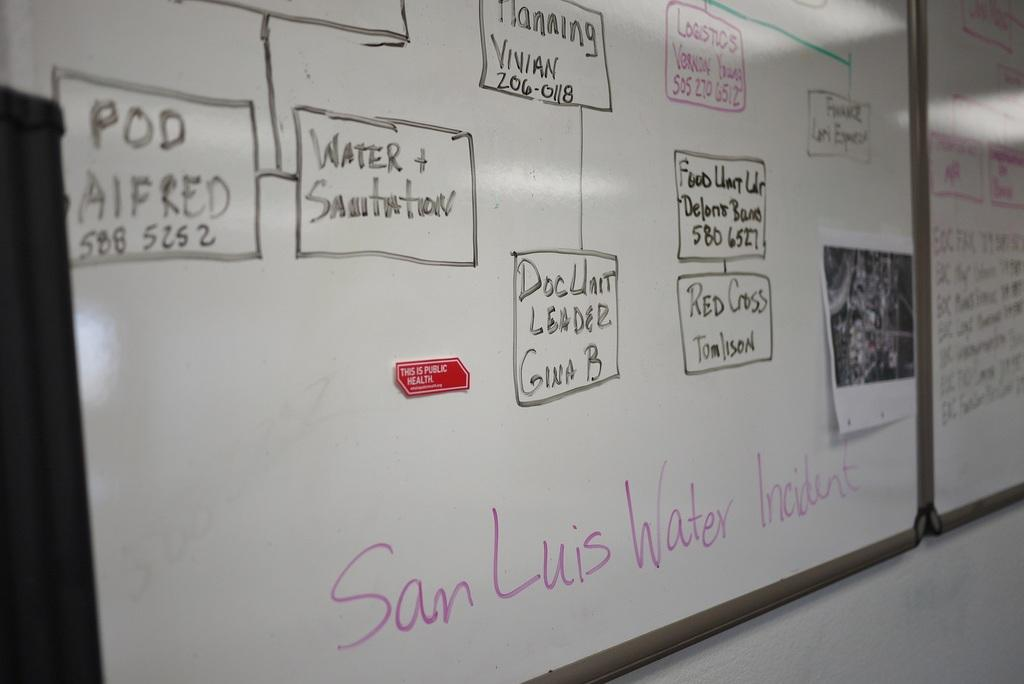<image>
Give a short and clear explanation of the subsequent image. A very organized time line tree is drawn on a white board above the heading San Luis Water Incident. 